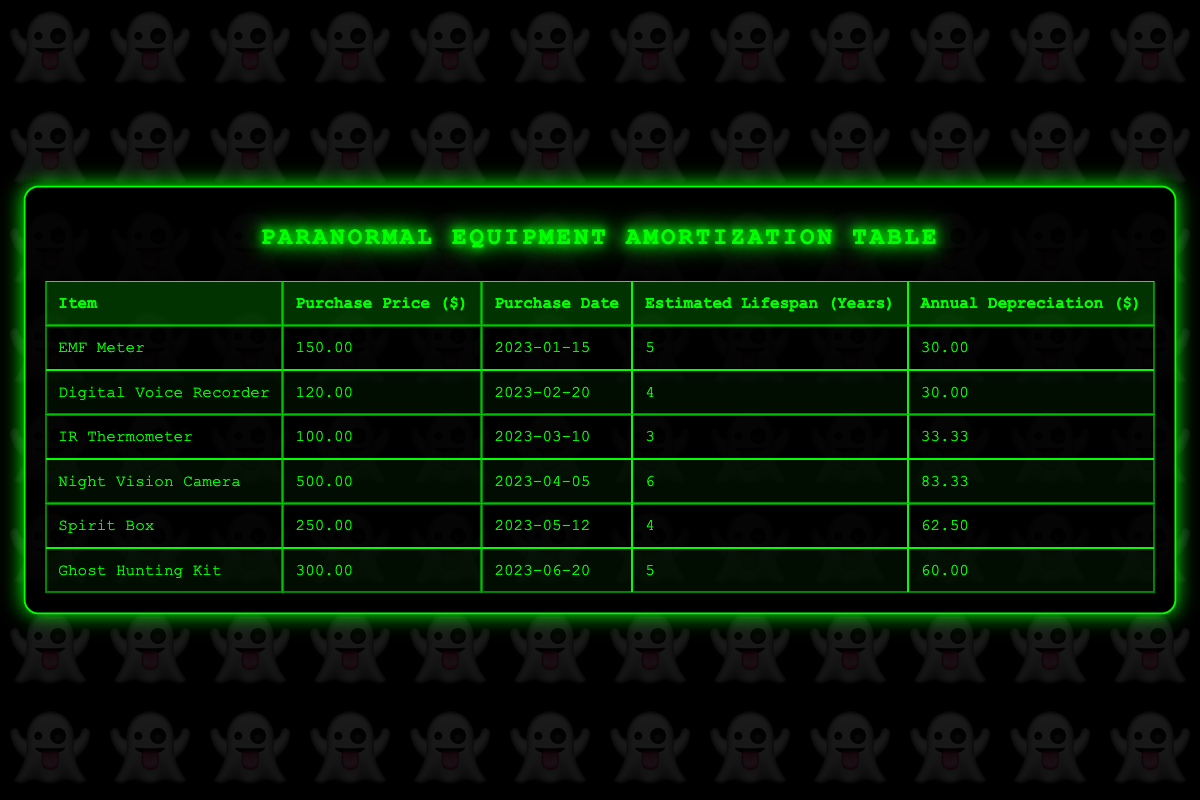What is the purchase price of the IR Thermometer? The table lists the IR Thermometer with a purchase price of 100.00 in the "Purchase Price ($)" column.
Answer: 100.00 What is the total estimated lifespan of all the equipment purchased? By adding up the estimated lifespans: 5 + 4 + 3 + 6 + 4 + 5 = 27 years.
Answer: 27 years Is the Annual Depreciation for the Night Vision Camera higher than that of the Spirit Box? The table shows that the Annual Depreciation for the Night Vision Camera is 83.33, while for the Spirit Box, it is 62.50. Since 83.33 > 62.50, the statement is true.
Answer: Yes What is the average Annual Depreciation of all items? To find the average, sum the Annual Depreciation: 30.00 + 30.00 + 33.33 + 83.33 + 62.50 + 60.00 = 298.16, then divide by the number of items (6): 298.16 / 6 ≈ 49.69.
Answer: 49.69 Which item has the highest purchase price? The Night Vision Camera has the highest purchase price at 500.00 based on the "Purchase Price ($)" column.
Answer: Night Vision Camera What is the total Annual Depreciation of the equipment purchased within 2023? The total Annual Depreciation is calculated by adding all the Annual Depreciation values: 30.00 + 30.00 + 33.33 + 83.33 + 62.50 + 60.00 = 298.16.
Answer: 298.16 Does the Ghost Hunting Kit have a shorter lifespan than the Digital Voice Recorder? The Ghost Hunting Kit has an estimated lifespan of 5 years, while the Digital Voice Recorder has 4 years. Since 5 > 4, the statement is false.
Answer: No Which equipment purchased has the longest lifespan and what is that lifespan? The item with the longest lifespan is the Night Vision Camera with an estimated lifespan of 6 years.
Answer: Night Vision Camera, 6 years 